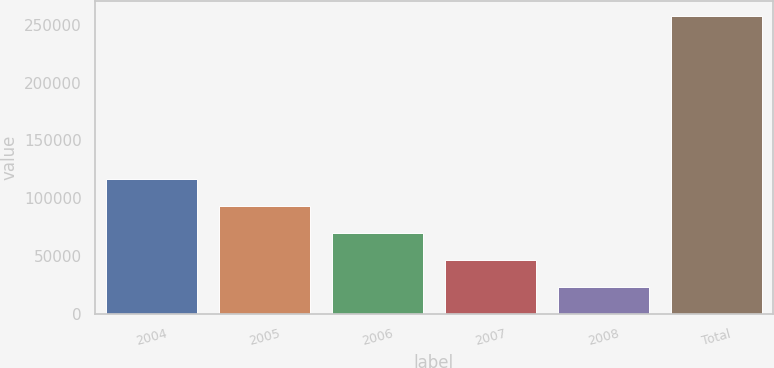<chart> <loc_0><loc_0><loc_500><loc_500><bar_chart><fcel>2004<fcel>2005<fcel>2006<fcel>2007<fcel>2008<fcel>Total<nl><fcel>116884<fcel>93494.8<fcel>70105.2<fcel>46715.6<fcel>23326<fcel>257222<nl></chart> 